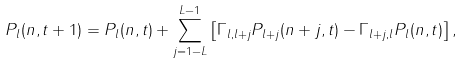Convert formula to latex. <formula><loc_0><loc_0><loc_500><loc_500>P _ { l } ( n , t + 1 ) = P _ { l } ( n , t ) + \sum _ { j = 1 - L } ^ { L - 1 } \left [ \Gamma _ { l , l + j } P _ { l + j } ( n + j , t ) - \Gamma _ { l + j , l } P _ { l } ( n , t ) \right ] ,</formula> 